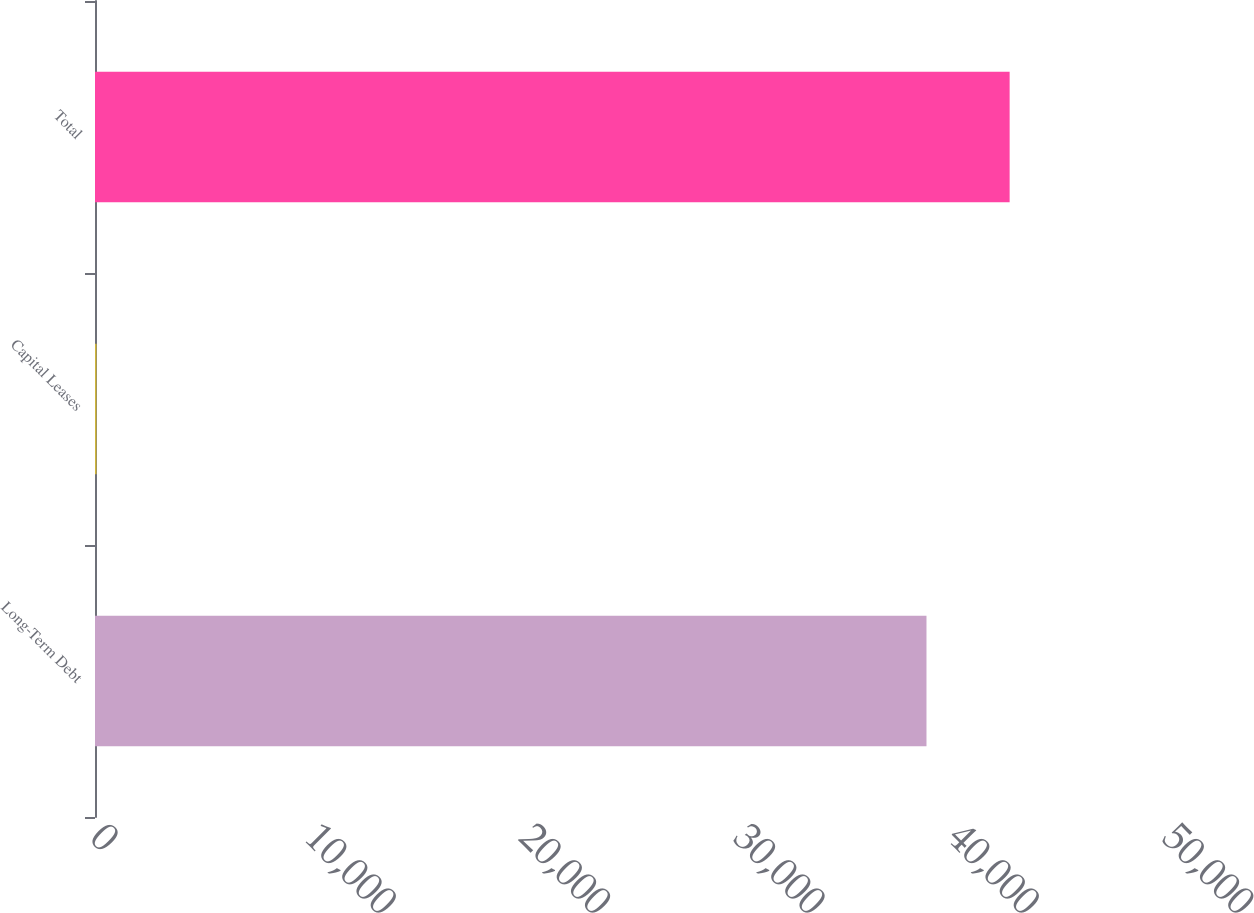Convert chart. <chart><loc_0><loc_0><loc_500><loc_500><bar_chart><fcel>Long-Term Debt<fcel>Capital Leases<fcel>Total<nl><fcel>38782<fcel>73<fcel>42660.2<nl></chart> 